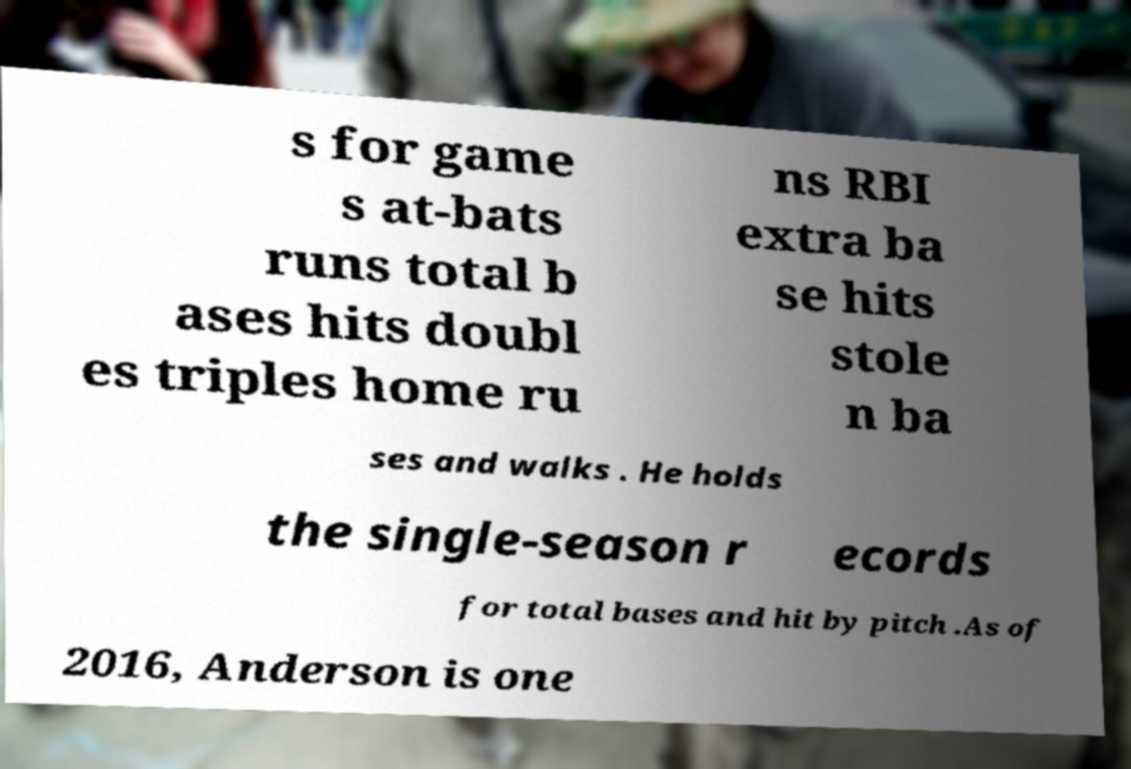Please identify and transcribe the text found in this image. s for game s at-bats runs total b ases hits doubl es triples home ru ns RBI extra ba se hits stole n ba ses and walks . He holds the single-season r ecords for total bases and hit by pitch .As of 2016, Anderson is one 